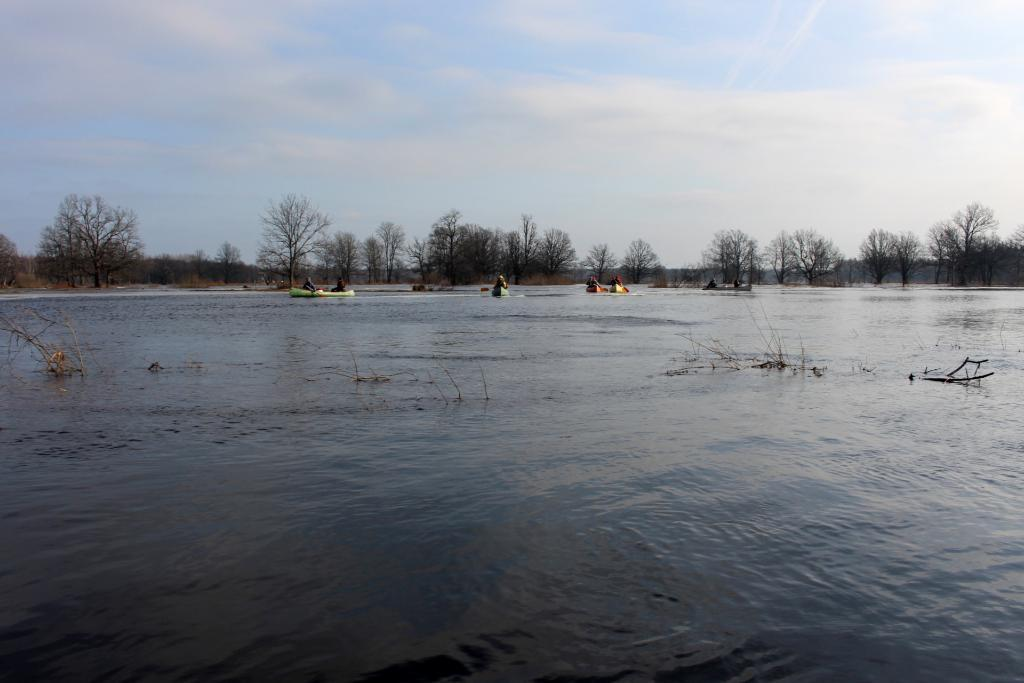What type of vegetation can be seen in the image? There are trees in the image. What is in the water in the image? There are boats in the water. How would you describe the sky in the image? The sky is blue and cloudy. What are the people in the boats doing? The people are sitting in the boats. What type of skin condition can be seen on the people in the boats? There is no indication of any skin condition on the people in the boats, as the image does not provide enough detail to make such a determination. Is there a zoo present in the image? No, there is no zoo present in the image; it features trees, boats, and people in the boats. 